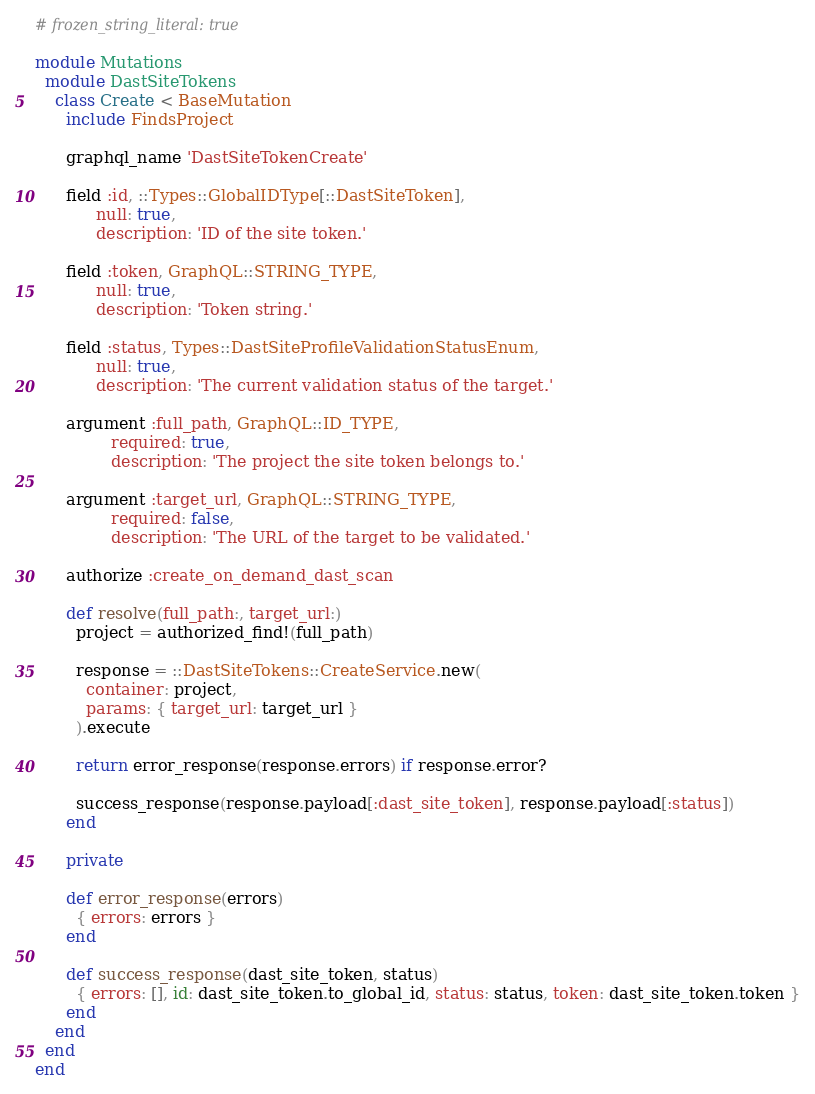Convert code to text. <code><loc_0><loc_0><loc_500><loc_500><_Ruby_># frozen_string_literal: true

module Mutations
  module DastSiteTokens
    class Create < BaseMutation
      include FindsProject

      graphql_name 'DastSiteTokenCreate'

      field :id, ::Types::GlobalIDType[::DastSiteToken],
            null: true,
            description: 'ID of the site token.'

      field :token, GraphQL::STRING_TYPE,
            null: true,
            description: 'Token string.'

      field :status, Types::DastSiteProfileValidationStatusEnum,
            null: true,
            description: 'The current validation status of the target.'

      argument :full_path, GraphQL::ID_TYPE,
               required: true,
               description: 'The project the site token belongs to.'

      argument :target_url, GraphQL::STRING_TYPE,
               required: false,
               description: 'The URL of the target to be validated.'

      authorize :create_on_demand_dast_scan

      def resolve(full_path:, target_url:)
        project = authorized_find!(full_path)

        response = ::DastSiteTokens::CreateService.new(
          container: project,
          params: { target_url: target_url }
        ).execute

        return error_response(response.errors) if response.error?

        success_response(response.payload[:dast_site_token], response.payload[:status])
      end

      private

      def error_response(errors)
        { errors: errors }
      end

      def success_response(dast_site_token, status)
        { errors: [], id: dast_site_token.to_global_id, status: status, token: dast_site_token.token }
      end
    end
  end
end
</code> 